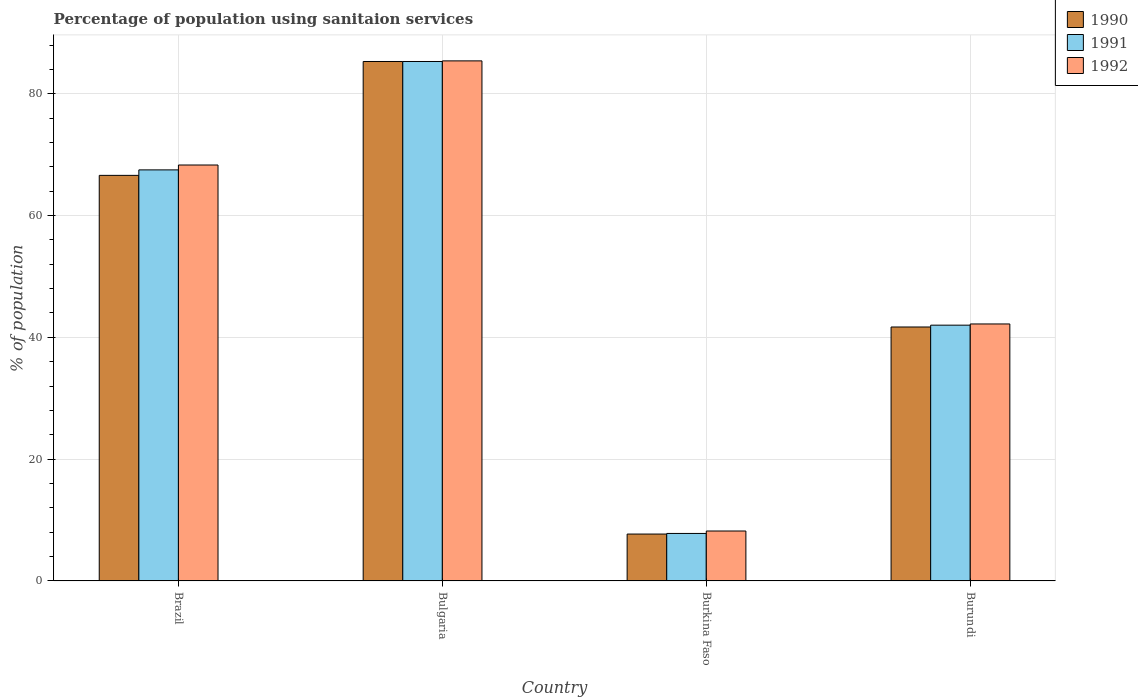How many different coloured bars are there?
Provide a succinct answer. 3. What is the label of the 1st group of bars from the left?
Offer a terse response. Brazil. Across all countries, what is the maximum percentage of population using sanitaion services in 1990?
Make the answer very short. 85.3. Across all countries, what is the minimum percentage of population using sanitaion services in 1991?
Give a very brief answer. 7.8. In which country was the percentage of population using sanitaion services in 1990 minimum?
Make the answer very short. Burkina Faso. What is the total percentage of population using sanitaion services in 1992 in the graph?
Provide a short and direct response. 204.1. What is the difference between the percentage of population using sanitaion services in 1991 in Brazil and that in Bulgaria?
Your answer should be very brief. -17.8. What is the difference between the percentage of population using sanitaion services in 1990 in Burundi and the percentage of population using sanitaion services in 1991 in Burkina Faso?
Offer a very short reply. 33.9. What is the average percentage of population using sanitaion services in 1991 per country?
Keep it short and to the point. 50.65. What is the difference between the percentage of population using sanitaion services of/in 1990 and percentage of population using sanitaion services of/in 1991 in Brazil?
Your answer should be very brief. -0.9. In how many countries, is the percentage of population using sanitaion services in 1991 greater than 80 %?
Your answer should be compact. 1. What is the ratio of the percentage of population using sanitaion services in 1991 in Brazil to that in Bulgaria?
Provide a short and direct response. 0.79. Is the difference between the percentage of population using sanitaion services in 1990 in Burkina Faso and Burundi greater than the difference between the percentage of population using sanitaion services in 1991 in Burkina Faso and Burundi?
Your answer should be very brief. Yes. What is the difference between the highest and the second highest percentage of population using sanitaion services in 1990?
Your answer should be compact. -24.9. What is the difference between the highest and the lowest percentage of population using sanitaion services in 1990?
Provide a succinct answer. 77.6. In how many countries, is the percentage of population using sanitaion services in 1992 greater than the average percentage of population using sanitaion services in 1992 taken over all countries?
Offer a terse response. 2. Is the sum of the percentage of population using sanitaion services in 1991 in Brazil and Bulgaria greater than the maximum percentage of population using sanitaion services in 1992 across all countries?
Give a very brief answer. Yes. What does the 1st bar from the left in Burkina Faso represents?
Your response must be concise. 1990. Is it the case that in every country, the sum of the percentage of population using sanitaion services in 1991 and percentage of population using sanitaion services in 1992 is greater than the percentage of population using sanitaion services in 1990?
Give a very brief answer. Yes. How many countries are there in the graph?
Make the answer very short. 4. Does the graph contain any zero values?
Provide a succinct answer. No. Where does the legend appear in the graph?
Offer a terse response. Top right. How many legend labels are there?
Give a very brief answer. 3. What is the title of the graph?
Keep it short and to the point. Percentage of population using sanitaion services. Does "1980" appear as one of the legend labels in the graph?
Keep it short and to the point. No. What is the label or title of the Y-axis?
Offer a very short reply. % of population. What is the % of population in 1990 in Brazil?
Your response must be concise. 66.6. What is the % of population of 1991 in Brazil?
Offer a terse response. 67.5. What is the % of population of 1992 in Brazil?
Keep it short and to the point. 68.3. What is the % of population of 1990 in Bulgaria?
Provide a short and direct response. 85.3. What is the % of population of 1991 in Bulgaria?
Offer a very short reply. 85.3. What is the % of population of 1992 in Bulgaria?
Offer a terse response. 85.4. What is the % of population in 1992 in Burkina Faso?
Keep it short and to the point. 8.2. What is the % of population in 1990 in Burundi?
Make the answer very short. 41.7. What is the % of population of 1992 in Burundi?
Your answer should be very brief. 42.2. Across all countries, what is the maximum % of population in 1990?
Provide a short and direct response. 85.3. Across all countries, what is the maximum % of population of 1991?
Make the answer very short. 85.3. Across all countries, what is the maximum % of population in 1992?
Offer a terse response. 85.4. Across all countries, what is the minimum % of population of 1992?
Provide a short and direct response. 8.2. What is the total % of population in 1990 in the graph?
Your answer should be very brief. 201.3. What is the total % of population in 1991 in the graph?
Your response must be concise. 202.6. What is the total % of population of 1992 in the graph?
Offer a terse response. 204.1. What is the difference between the % of population in 1990 in Brazil and that in Bulgaria?
Offer a very short reply. -18.7. What is the difference between the % of population of 1991 in Brazil and that in Bulgaria?
Ensure brevity in your answer.  -17.8. What is the difference between the % of population of 1992 in Brazil and that in Bulgaria?
Your response must be concise. -17.1. What is the difference between the % of population in 1990 in Brazil and that in Burkina Faso?
Your answer should be very brief. 58.9. What is the difference between the % of population of 1991 in Brazil and that in Burkina Faso?
Your answer should be compact. 59.7. What is the difference between the % of population in 1992 in Brazil and that in Burkina Faso?
Your response must be concise. 60.1. What is the difference between the % of population of 1990 in Brazil and that in Burundi?
Ensure brevity in your answer.  24.9. What is the difference between the % of population in 1992 in Brazil and that in Burundi?
Your response must be concise. 26.1. What is the difference between the % of population of 1990 in Bulgaria and that in Burkina Faso?
Provide a succinct answer. 77.6. What is the difference between the % of population in 1991 in Bulgaria and that in Burkina Faso?
Ensure brevity in your answer.  77.5. What is the difference between the % of population of 1992 in Bulgaria and that in Burkina Faso?
Provide a succinct answer. 77.2. What is the difference between the % of population of 1990 in Bulgaria and that in Burundi?
Ensure brevity in your answer.  43.6. What is the difference between the % of population in 1991 in Bulgaria and that in Burundi?
Your response must be concise. 43.3. What is the difference between the % of population of 1992 in Bulgaria and that in Burundi?
Give a very brief answer. 43.2. What is the difference between the % of population of 1990 in Burkina Faso and that in Burundi?
Keep it short and to the point. -34. What is the difference between the % of population in 1991 in Burkina Faso and that in Burundi?
Your answer should be very brief. -34.2. What is the difference between the % of population in 1992 in Burkina Faso and that in Burundi?
Your response must be concise. -34. What is the difference between the % of population of 1990 in Brazil and the % of population of 1991 in Bulgaria?
Provide a succinct answer. -18.7. What is the difference between the % of population in 1990 in Brazil and the % of population in 1992 in Bulgaria?
Your answer should be compact. -18.8. What is the difference between the % of population of 1991 in Brazil and the % of population of 1992 in Bulgaria?
Make the answer very short. -17.9. What is the difference between the % of population in 1990 in Brazil and the % of population in 1991 in Burkina Faso?
Your answer should be compact. 58.8. What is the difference between the % of population in 1990 in Brazil and the % of population in 1992 in Burkina Faso?
Offer a terse response. 58.4. What is the difference between the % of population of 1991 in Brazil and the % of population of 1992 in Burkina Faso?
Offer a very short reply. 59.3. What is the difference between the % of population in 1990 in Brazil and the % of population in 1991 in Burundi?
Ensure brevity in your answer.  24.6. What is the difference between the % of population of 1990 in Brazil and the % of population of 1992 in Burundi?
Ensure brevity in your answer.  24.4. What is the difference between the % of population of 1991 in Brazil and the % of population of 1992 in Burundi?
Make the answer very short. 25.3. What is the difference between the % of population of 1990 in Bulgaria and the % of population of 1991 in Burkina Faso?
Make the answer very short. 77.5. What is the difference between the % of population in 1990 in Bulgaria and the % of population in 1992 in Burkina Faso?
Provide a succinct answer. 77.1. What is the difference between the % of population in 1991 in Bulgaria and the % of population in 1992 in Burkina Faso?
Provide a succinct answer. 77.1. What is the difference between the % of population of 1990 in Bulgaria and the % of population of 1991 in Burundi?
Your answer should be compact. 43.3. What is the difference between the % of population of 1990 in Bulgaria and the % of population of 1992 in Burundi?
Your response must be concise. 43.1. What is the difference between the % of population in 1991 in Bulgaria and the % of population in 1992 in Burundi?
Offer a very short reply. 43.1. What is the difference between the % of population in 1990 in Burkina Faso and the % of population in 1991 in Burundi?
Give a very brief answer. -34.3. What is the difference between the % of population of 1990 in Burkina Faso and the % of population of 1992 in Burundi?
Your response must be concise. -34.5. What is the difference between the % of population of 1991 in Burkina Faso and the % of population of 1992 in Burundi?
Offer a terse response. -34.4. What is the average % of population of 1990 per country?
Your response must be concise. 50.33. What is the average % of population of 1991 per country?
Provide a succinct answer. 50.65. What is the average % of population of 1992 per country?
Give a very brief answer. 51.02. What is the difference between the % of population of 1990 and % of population of 1992 in Brazil?
Keep it short and to the point. -1.7. What is the difference between the % of population of 1991 and % of population of 1992 in Brazil?
Ensure brevity in your answer.  -0.8. What is the difference between the % of population of 1990 and % of population of 1991 in Bulgaria?
Offer a very short reply. 0. What is the difference between the % of population in 1991 and % of population in 1992 in Burkina Faso?
Make the answer very short. -0.4. What is the difference between the % of population in 1990 and % of population in 1992 in Burundi?
Your answer should be very brief. -0.5. What is the ratio of the % of population in 1990 in Brazil to that in Bulgaria?
Offer a very short reply. 0.78. What is the ratio of the % of population in 1991 in Brazil to that in Bulgaria?
Offer a terse response. 0.79. What is the ratio of the % of population of 1992 in Brazil to that in Bulgaria?
Offer a very short reply. 0.8. What is the ratio of the % of population of 1990 in Brazil to that in Burkina Faso?
Your response must be concise. 8.65. What is the ratio of the % of population in 1991 in Brazil to that in Burkina Faso?
Ensure brevity in your answer.  8.65. What is the ratio of the % of population in 1992 in Brazil to that in Burkina Faso?
Ensure brevity in your answer.  8.33. What is the ratio of the % of population in 1990 in Brazil to that in Burundi?
Offer a terse response. 1.6. What is the ratio of the % of population of 1991 in Brazil to that in Burundi?
Your response must be concise. 1.61. What is the ratio of the % of population of 1992 in Brazil to that in Burundi?
Provide a succinct answer. 1.62. What is the ratio of the % of population of 1990 in Bulgaria to that in Burkina Faso?
Ensure brevity in your answer.  11.08. What is the ratio of the % of population of 1991 in Bulgaria to that in Burkina Faso?
Offer a terse response. 10.94. What is the ratio of the % of population of 1992 in Bulgaria to that in Burkina Faso?
Offer a very short reply. 10.41. What is the ratio of the % of population in 1990 in Bulgaria to that in Burundi?
Offer a very short reply. 2.05. What is the ratio of the % of population in 1991 in Bulgaria to that in Burundi?
Provide a succinct answer. 2.03. What is the ratio of the % of population in 1992 in Bulgaria to that in Burundi?
Keep it short and to the point. 2.02. What is the ratio of the % of population in 1990 in Burkina Faso to that in Burundi?
Give a very brief answer. 0.18. What is the ratio of the % of population in 1991 in Burkina Faso to that in Burundi?
Your answer should be very brief. 0.19. What is the ratio of the % of population of 1992 in Burkina Faso to that in Burundi?
Provide a succinct answer. 0.19. What is the difference between the highest and the second highest % of population in 1991?
Offer a terse response. 17.8. What is the difference between the highest and the lowest % of population of 1990?
Offer a very short reply. 77.6. What is the difference between the highest and the lowest % of population of 1991?
Your response must be concise. 77.5. What is the difference between the highest and the lowest % of population in 1992?
Provide a short and direct response. 77.2. 